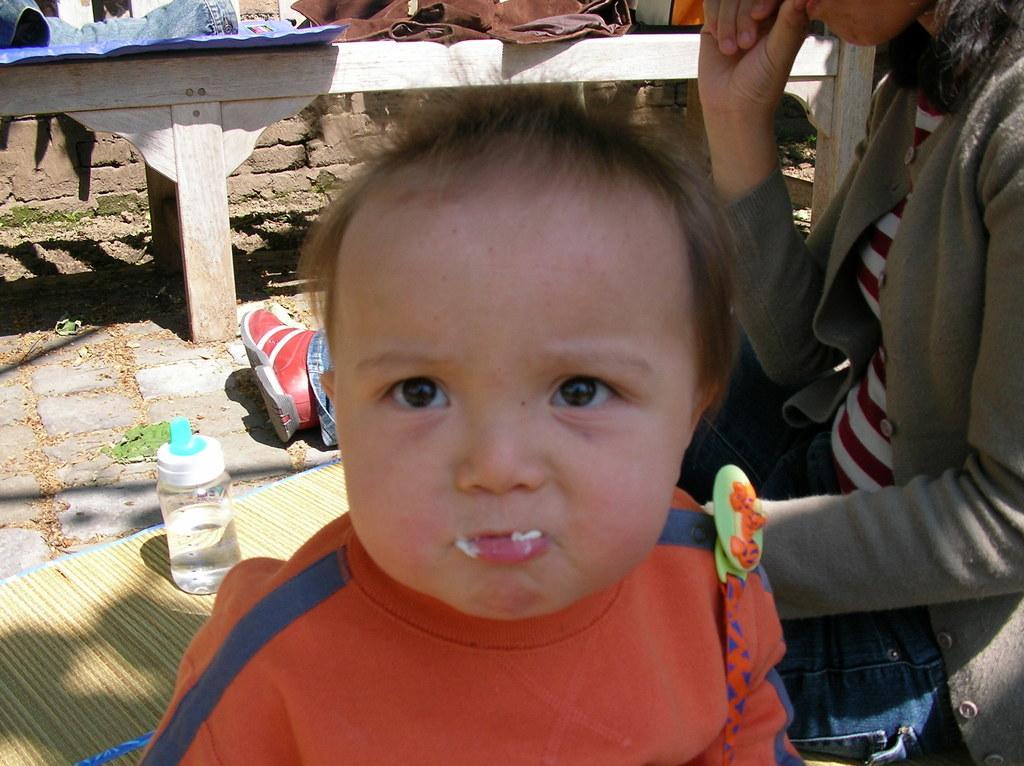How would you summarize this image in a sentence or two? In this image in front there is a baby. Behind the baby there is a person. In front of her there is a water bottle on the mat. In the background of the image there is a table. On top of it there are a few objects. 